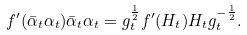<formula> <loc_0><loc_0><loc_500><loc_500>f ^ { \prime } ( \bar { \alpha } _ { t } \alpha _ { t } ) \bar { \alpha } _ { t } \alpha _ { t } = g _ { t } ^ { \frac { 1 } { 2 } } f ^ { \prime } ( H _ { t } ) H _ { t } g _ { t } ^ { - \frac { 1 } { 2 } } .</formula> 